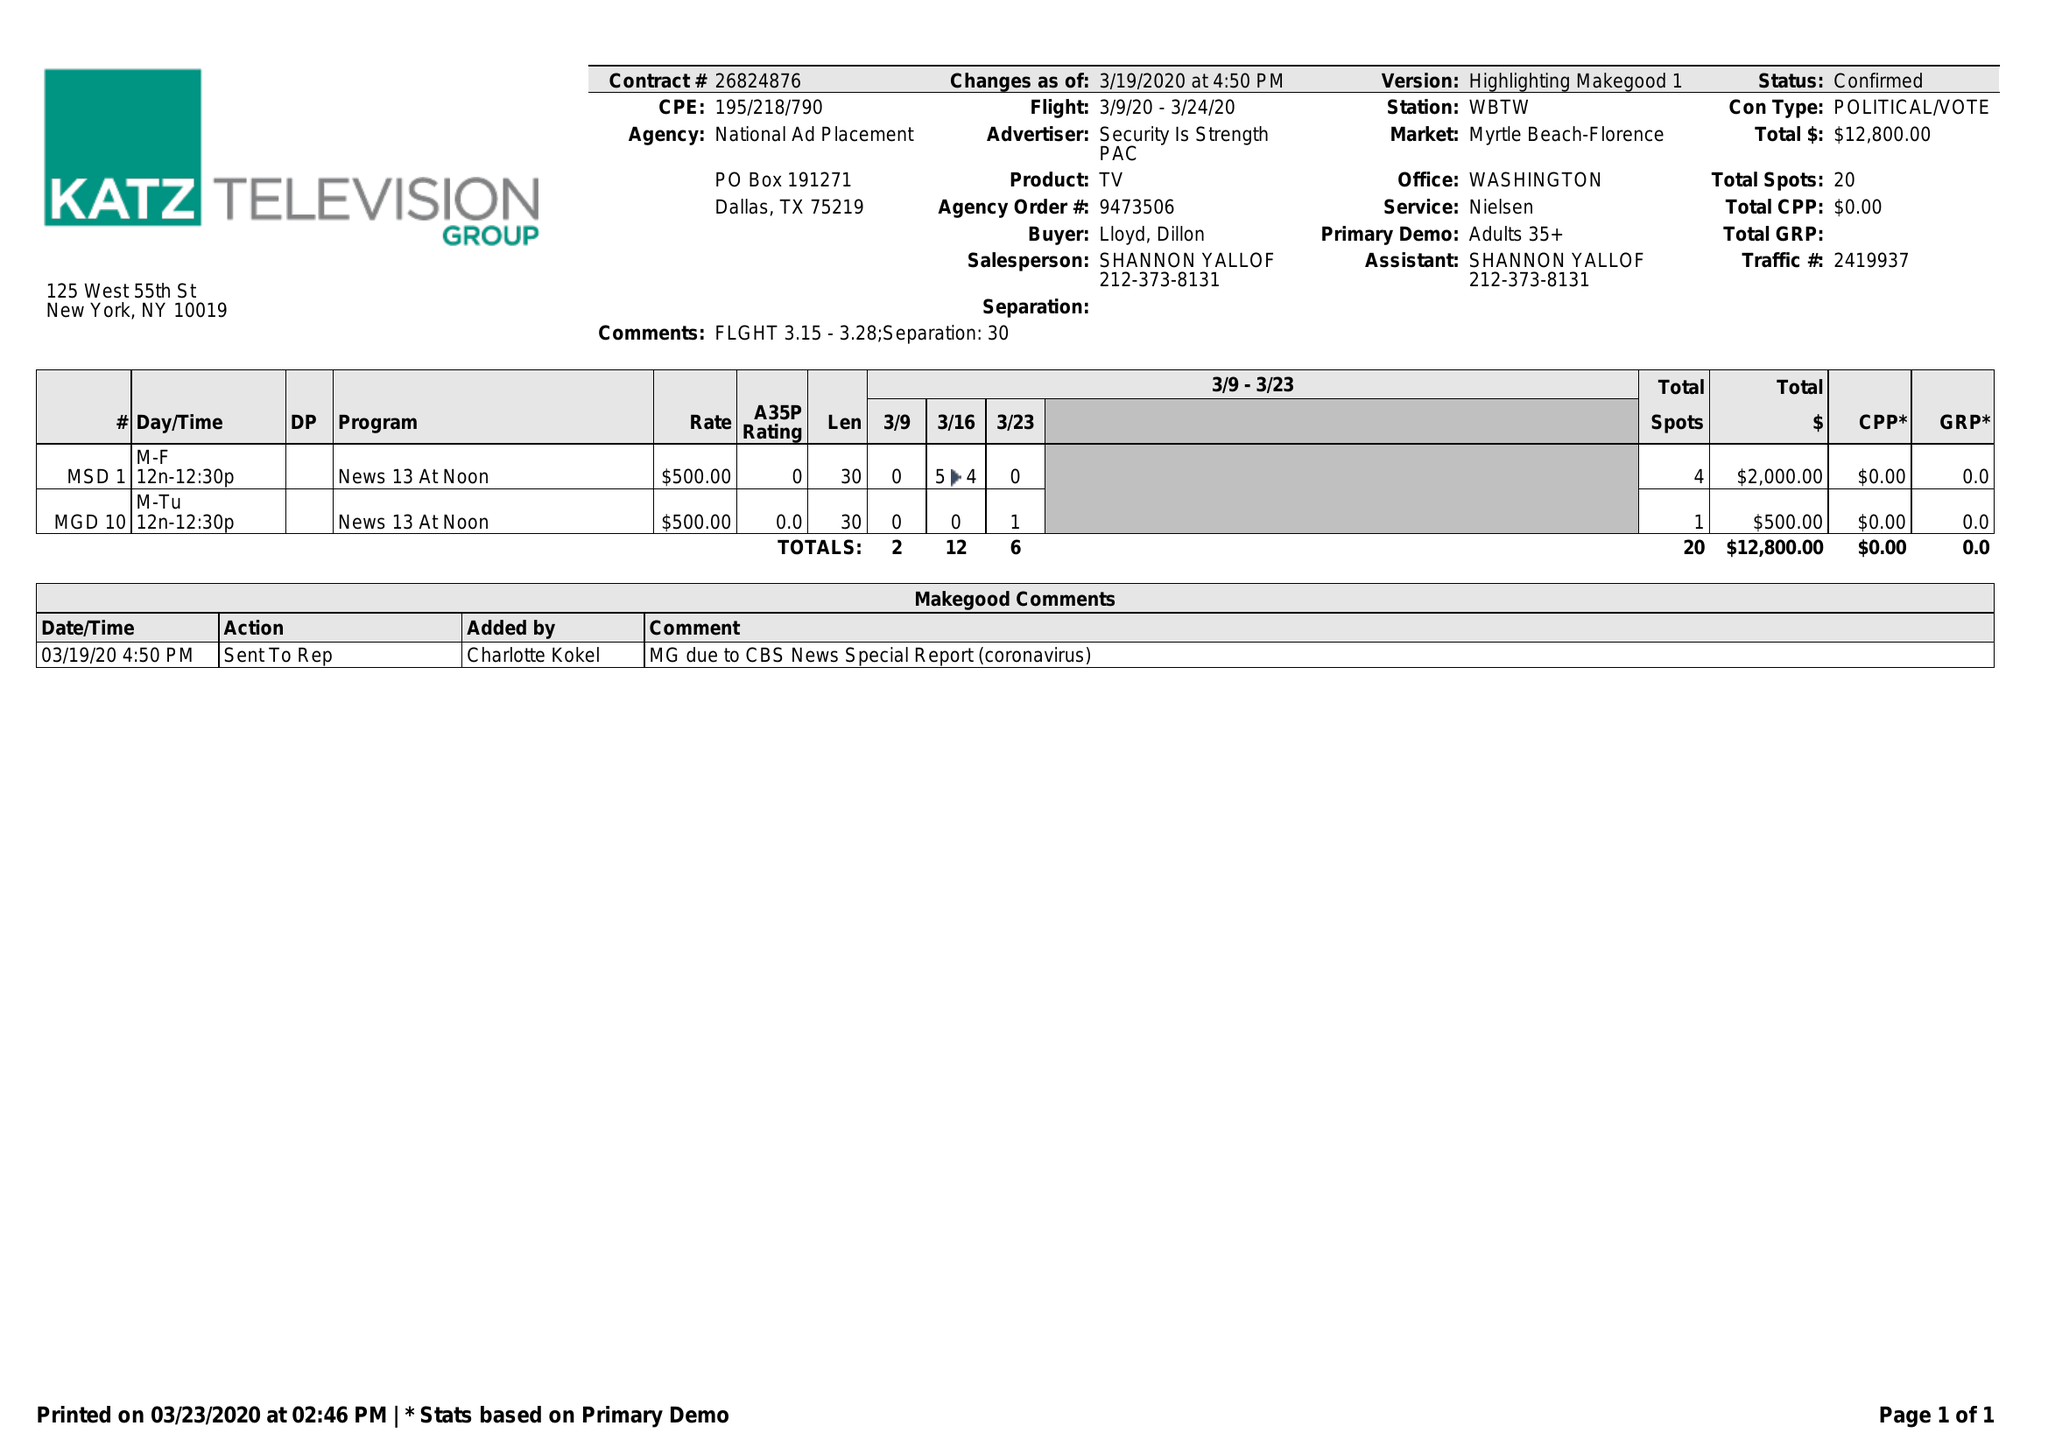What is the value for the flight_to?
Answer the question using a single word or phrase. 03/24/20 